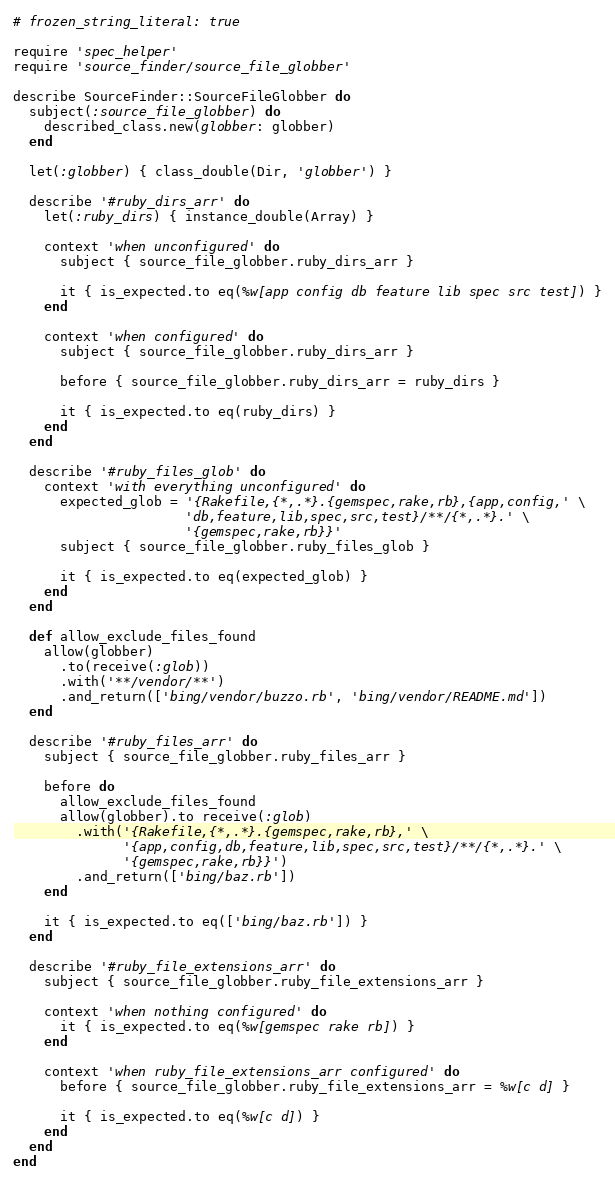<code> <loc_0><loc_0><loc_500><loc_500><_Ruby_># frozen_string_literal: true

require 'spec_helper'
require 'source_finder/source_file_globber'

describe SourceFinder::SourceFileGlobber do
  subject(:source_file_globber) do
    described_class.new(globber: globber)
  end

  let(:globber) { class_double(Dir, 'globber') }

  describe '#ruby_dirs_arr' do
    let(:ruby_dirs) { instance_double(Array) }

    context 'when unconfigured' do
      subject { source_file_globber.ruby_dirs_arr }

      it { is_expected.to eq(%w[app config db feature lib spec src test]) }
    end

    context 'when configured' do
      subject { source_file_globber.ruby_dirs_arr }

      before { source_file_globber.ruby_dirs_arr = ruby_dirs }

      it { is_expected.to eq(ruby_dirs) }
    end
  end

  describe '#ruby_files_glob' do
    context 'with everything unconfigured' do
      expected_glob = '{Rakefile,{*,.*}.{gemspec,rake,rb},{app,config,' \
                      'db,feature,lib,spec,src,test}/**/{*,.*}.' \
                      '{gemspec,rake,rb}}'
      subject { source_file_globber.ruby_files_glob }

      it { is_expected.to eq(expected_glob) }
    end
  end

  def allow_exclude_files_found
    allow(globber)
      .to(receive(:glob))
      .with('**/vendor/**')
      .and_return(['bing/vendor/buzzo.rb', 'bing/vendor/README.md'])
  end

  describe '#ruby_files_arr' do
    subject { source_file_globber.ruby_files_arr }

    before do
      allow_exclude_files_found
      allow(globber).to receive(:glob)
        .with('{Rakefile,{*,.*}.{gemspec,rake,rb},' \
              '{app,config,db,feature,lib,spec,src,test}/**/{*,.*}.' \
              '{gemspec,rake,rb}}')
        .and_return(['bing/baz.rb'])
    end

    it { is_expected.to eq(['bing/baz.rb']) }
  end

  describe '#ruby_file_extensions_arr' do
    subject { source_file_globber.ruby_file_extensions_arr }

    context 'when nothing configured' do
      it { is_expected.to eq(%w[gemspec rake rb]) }
    end

    context 'when ruby_file_extensions_arr configured' do
      before { source_file_globber.ruby_file_extensions_arr = %w[c d] }

      it { is_expected.to eq(%w[c d]) }
    end
  end
end
</code> 